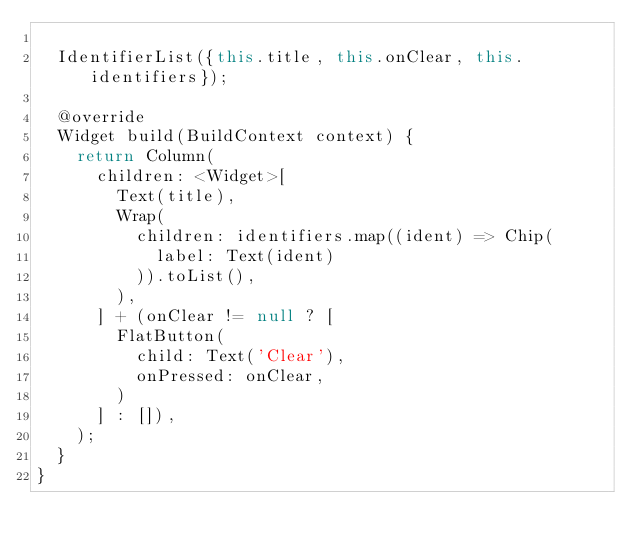Convert code to text. <code><loc_0><loc_0><loc_500><loc_500><_Dart_>
  IdentifierList({this.title, this.onClear, this.identifiers});

  @override
  Widget build(BuildContext context) {
    return Column(
      children: <Widget>[
        Text(title),
        Wrap(
          children: identifiers.map((ident) => Chip(
            label: Text(ident)
          )).toList(),
        ),
      ] + (onClear != null ? [
        FlatButton(
          child: Text('Clear'),
          onPressed: onClear,
        )
      ] : []),
    );
  }
}
</code> 